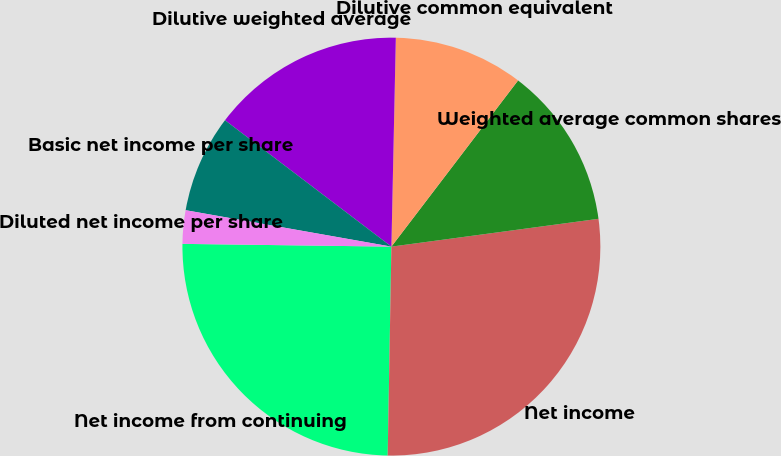Convert chart to OTSL. <chart><loc_0><loc_0><loc_500><loc_500><pie_chart><fcel>Net income from continuing<fcel>Net income<fcel>Weighted average common shares<fcel>Dilutive common equivalent<fcel>Dilutive weighted average<fcel>Basic net income per share<fcel>Diluted net income per share<nl><fcel>24.93%<fcel>27.41%<fcel>12.51%<fcel>10.03%<fcel>15.0%<fcel>7.55%<fcel>2.58%<nl></chart> 